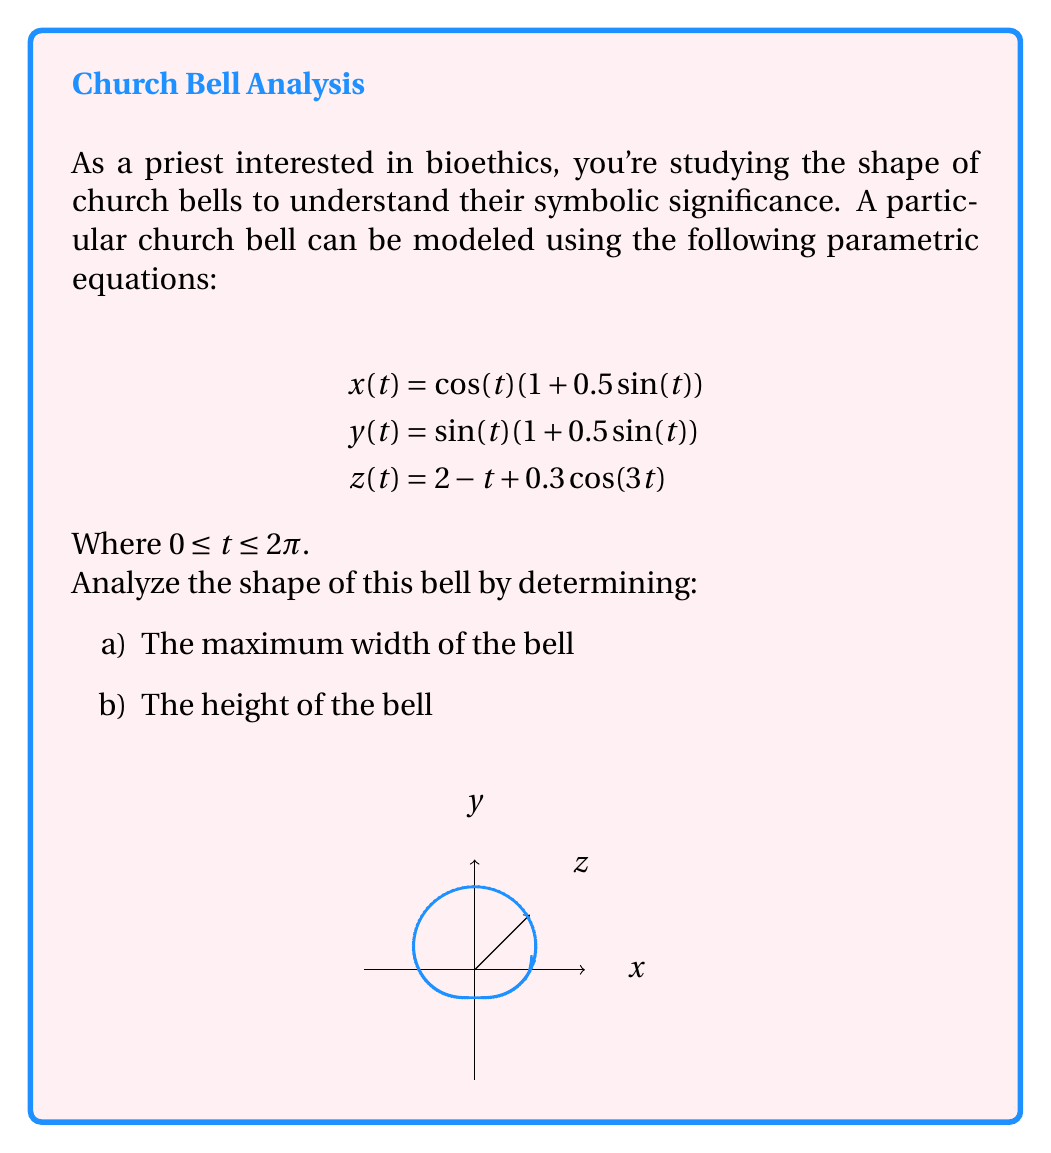Provide a solution to this math problem. Let's approach this problem step by step:

1) To find the maximum width of the bell, we need to find the maximum value of $\sqrt{x^2 + y^2}$.

   $$\sqrt{x^2 + y^2} = \sqrt{(\cos(t)(1+0.5\sin(t)))^2 + (\sin(t)(1+0.5\sin(t)))^2}$$
   $$= \sqrt{(\cos^2(t) + \sin^2(t))(1+0.5\sin(t))^2}$$
   $$= \sqrt{1 \cdot (1+0.5\sin(t))^2} = 1+0.5\sin(t)$$

   The maximum value of this occurs when $\sin(t) = 1$, giving a maximum width of 1.5.

2) For the height of the bell, we need to find the difference between the maximum and minimum values of $z(t)$.

   $$z(t) = 2 - t + 0.3\cos(3t)$$

   The maximum value occurs at $t = 0$:
   $$z_{max} = 2 - 0 + 0.3\cos(0) = 2.3$$

   The minimum value occurs at $t = 2\pi$:
   $$z_{min} = 2 - 2\pi + 0.3\cos(6\pi) = 2 - 2\pi + 0.3 = 2.3 - 2\pi$$

   Therefore, the height of the bell is:
   $$z_{max} - z_{min} = 2.3 - (2.3 - 2\pi) = 2\pi$$
Answer: a) 1.5
b) $2\pi$ 